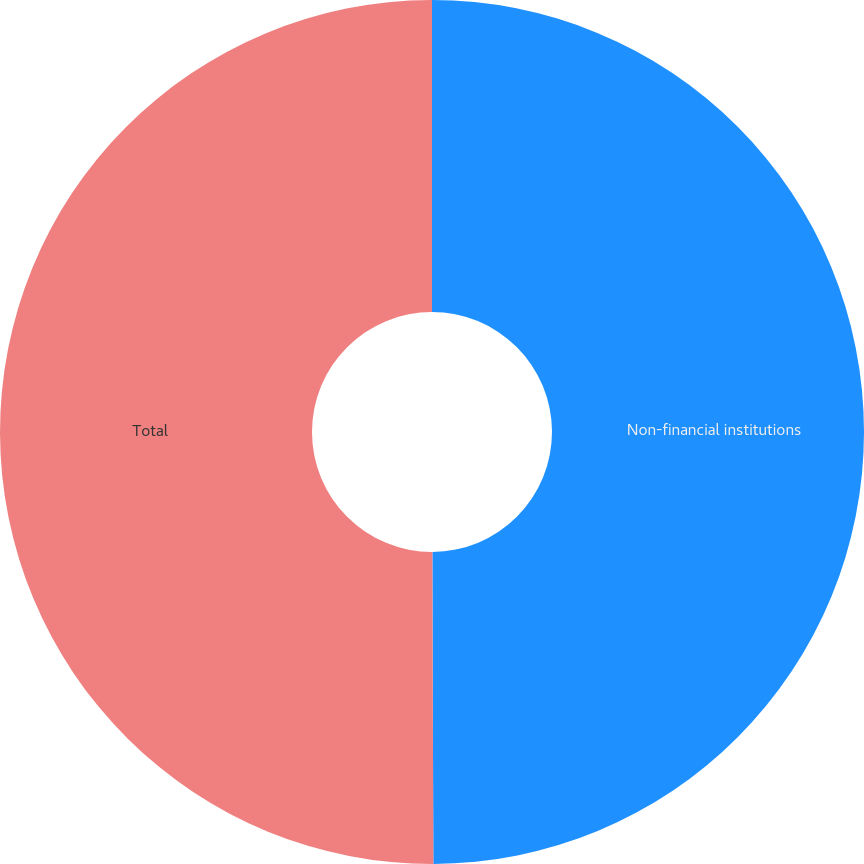Convert chart. <chart><loc_0><loc_0><loc_500><loc_500><pie_chart><fcel>Non-financial institutions<fcel>Total<nl><fcel>49.95%<fcel>50.05%<nl></chart> 